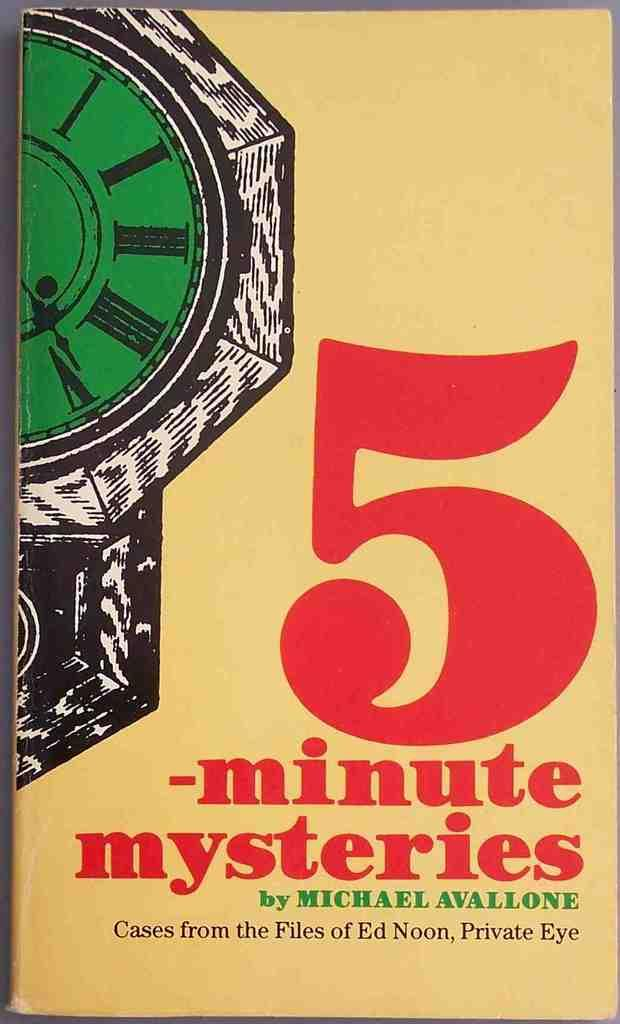<image>
Give a short and clear explanation of the subsequent image. A book by Michael Avallone with a clock on it with a green dial and the number 5 big on the cover. 